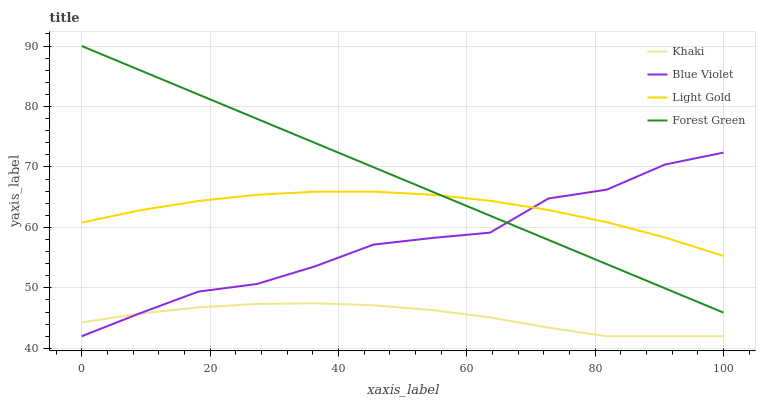Does Khaki have the minimum area under the curve?
Answer yes or no. Yes. Does Forest Green have the maximum area under the curve?
Answer yes or no. Yes. Does Light Gold have the minimum area under the curve?
Answer yes or no. No. Does Light Gold have the maximum area under the curve?
Answer yes or no. No. Is Forest Green the smoothest?
Answer yes or no. Yes. Is Blue Violet the roughest?
Answer yes or no. Yes. Is Khaki the smoothest?
Answer yes or no. No. Is Khaki the roughest?
Answer yes or no. No. Does Khaki have the lowest value?
Answer yes or no. Yes. Does Light Gold have the lowest value?
Answer yes or no. No. Does Forest Green have the highest value?
Answer yes or no. Yes. Does Light Gold have the highest value?
Answer yes or no. No. Is Khaki less than Light Gold?
Answer yes or no. Yes. Is Light Gold greater than Khaki?
Answer yes or no. Yes. Does Light Gold intersect Blue Violet?
Answer yes or no. Yes. Is Light Gold less than Blue Violet?
Answer yes or no. No. Is Light Gold greater than Blue Violet?
Answer yes or no. No. Does Khaki intersect Light Gold?
Answer yes or no. No. 